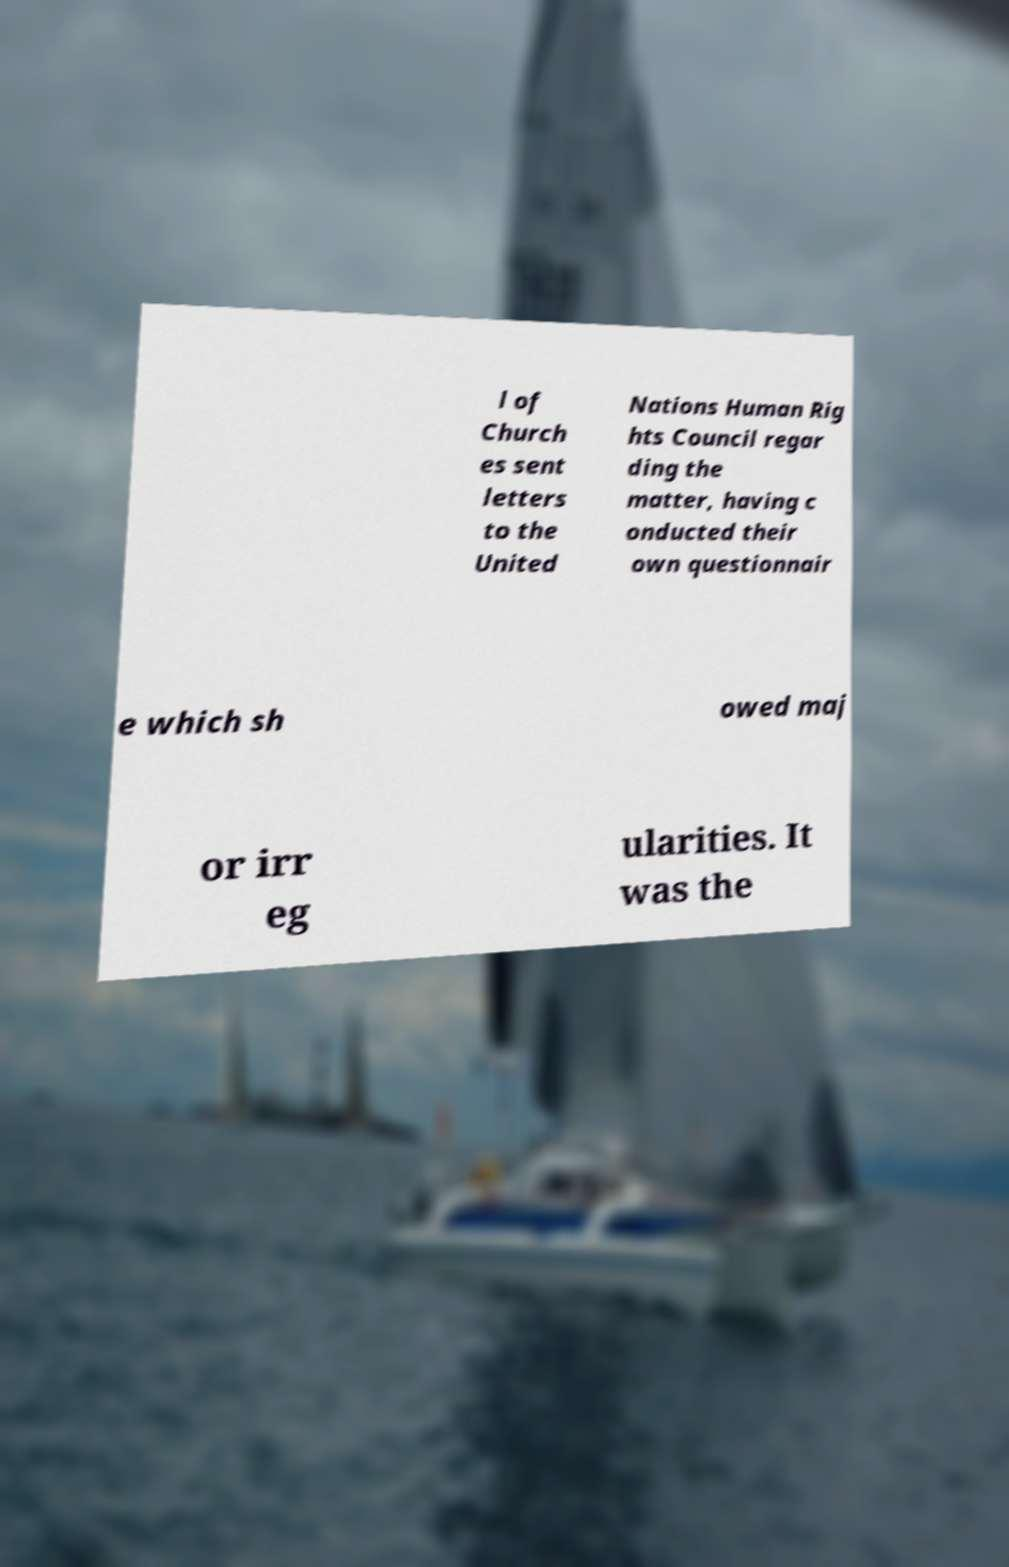What messages or text are displayed in this image? I need them in a readable, typed format. l of Church es sent letters to the United Nations Human Rig hts Council regar ding the matter, having c onducted their own questionnair e which sh owed maj or irr eg ularities. It was the 